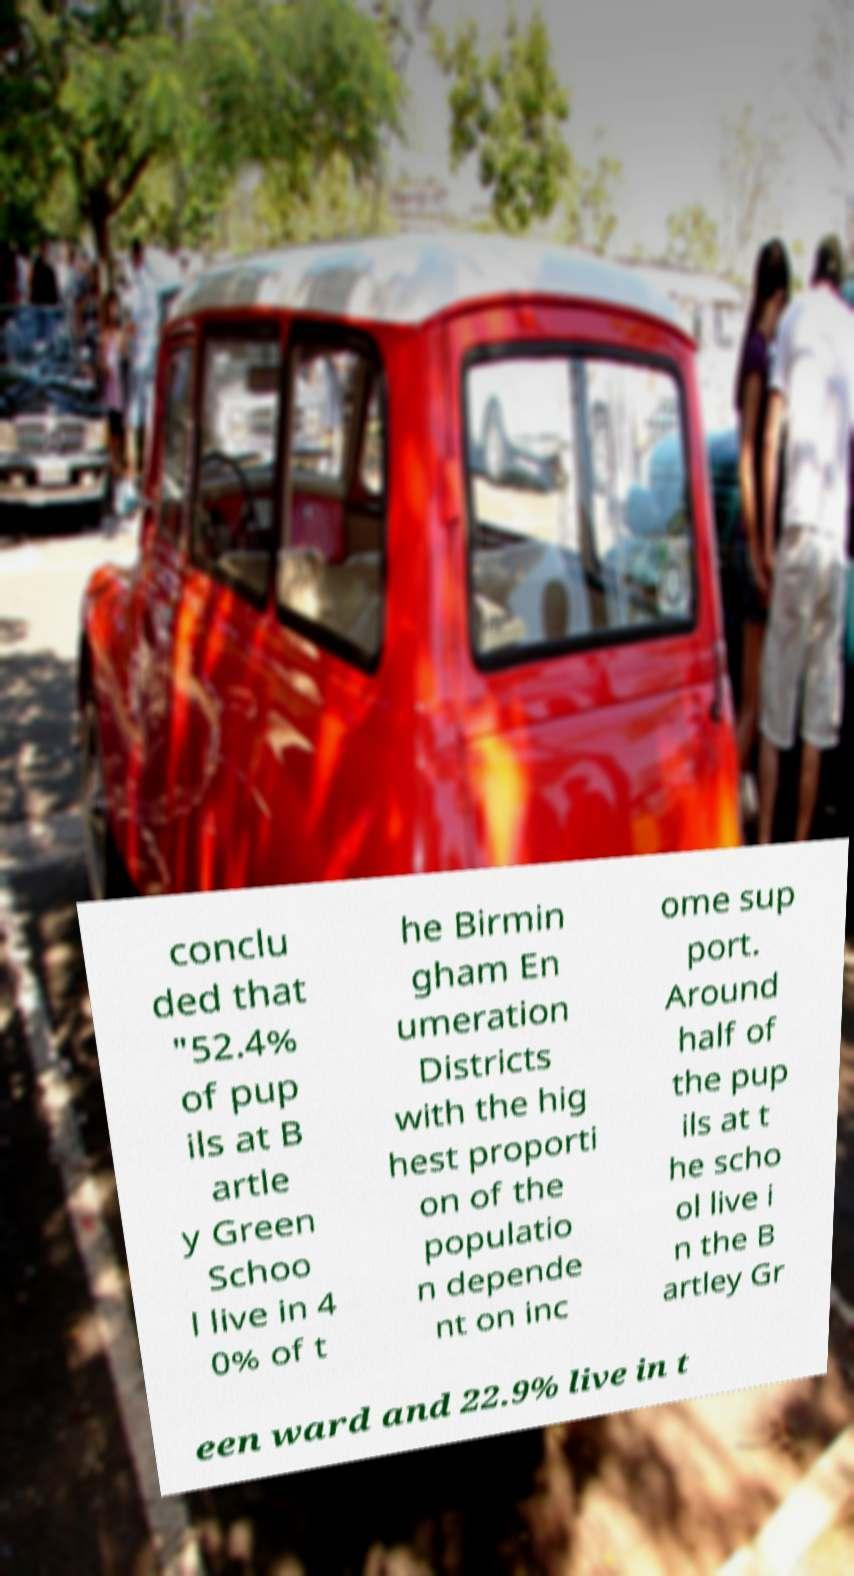What messages or text are displayed in this image? I need them in a readable, typed format. conclu ded that "52.4% of pup ils at B artle y Green Schoo l live in 4 0% of t he Birmin gham En umeration Districts with the hig hest proporti on of the populatio n depende nt on inc ome sup port. Around half of the pup ils at t he scho ol live i n the B artley Gr een ward and 22.9% live in t 